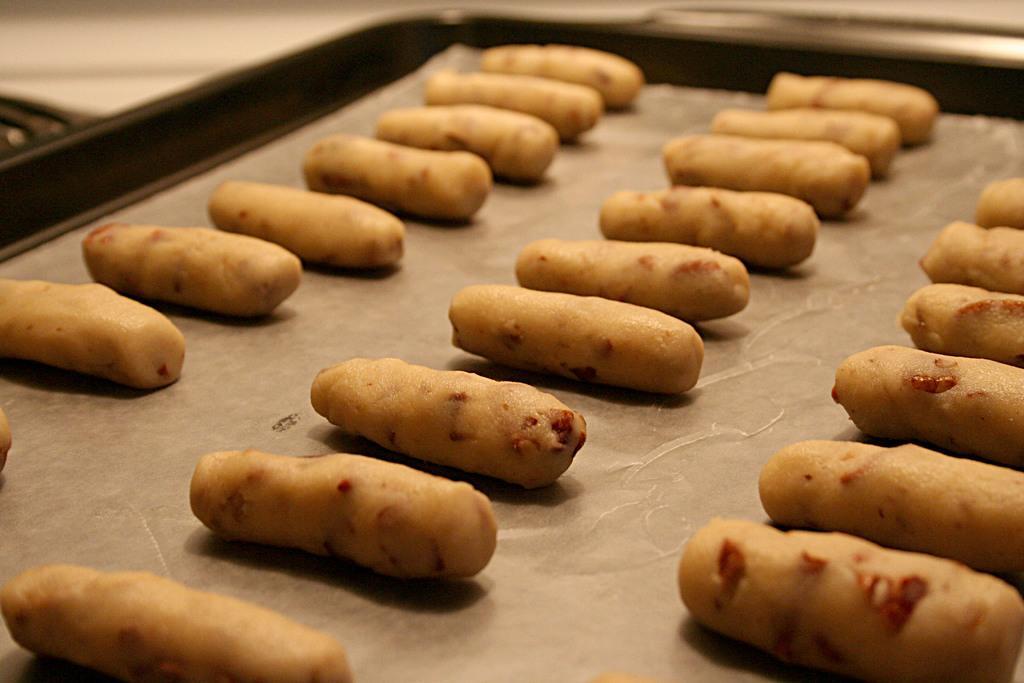Please provide a concise description of this image. In the image there is a tray with white paper and few snacks on it. 